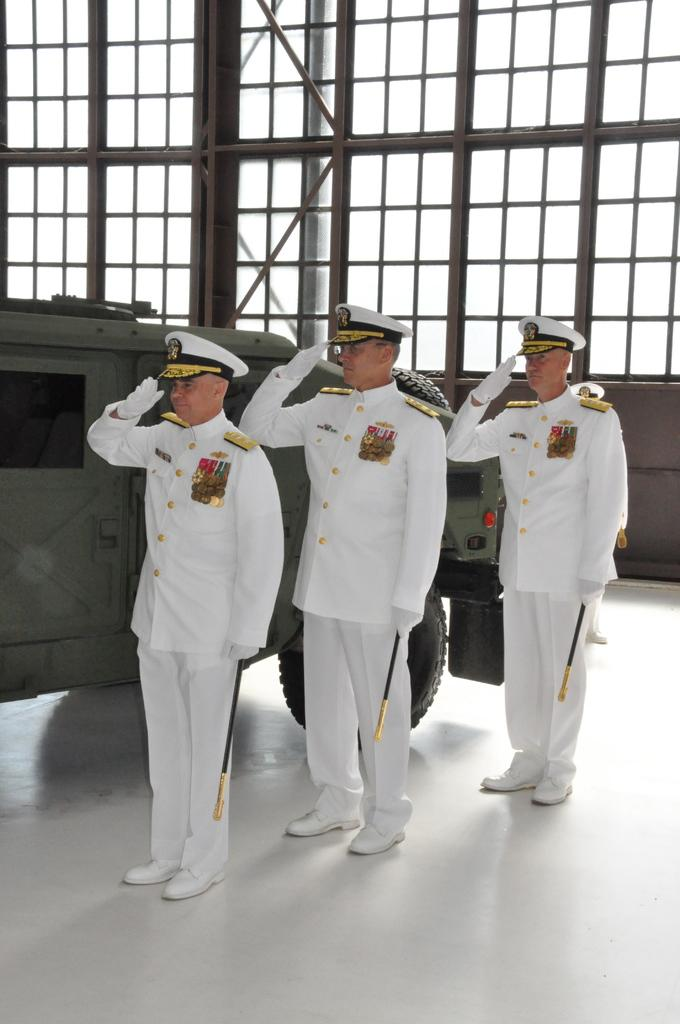How many men are in the image? There are three men in the image. What are the men wearing on their heads? The men are wearing caps. Where are the men standing? The men are standing on the floor. What are the men holding in their hands? The men are holding sticks in their hands. What else can be seen in the image besides the men? There is a vehicle in the image. What can be seen behind the men? There are windows visible at the back of the men. What type of pie is being served on the vehicle in the image? There is no pie present in the image; the men are holding sticks and there is no mention of food. 